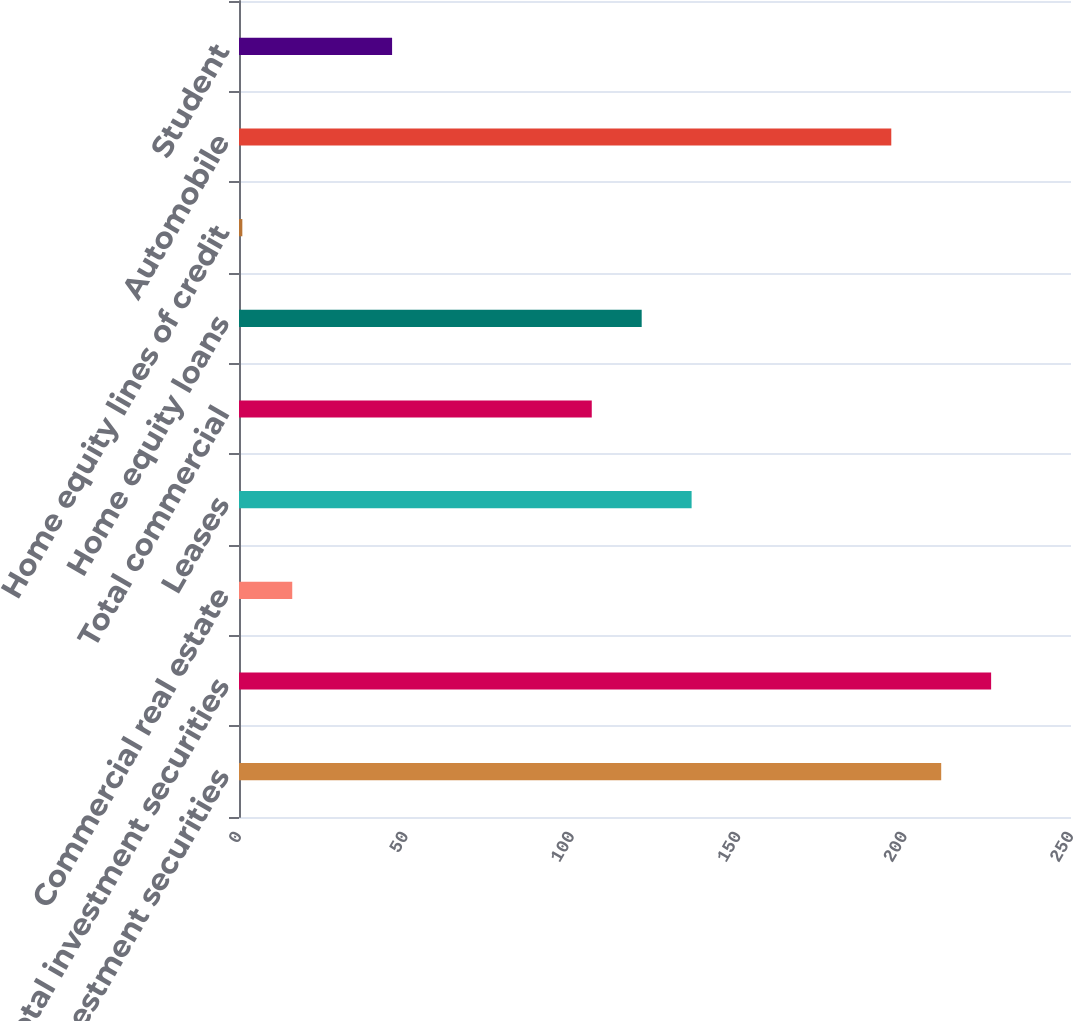Convert chart to OTSL. <chart><loc_0><loc_0><loc_500><loc_500><bar_chart><fcel>Taxable investment securities<fcel>Total investment securities<fcel>Commercial real estate<fcel>Leases<fcel>Total commercial<fcel>Home equity loans<fcel>Home equity lines of credit<fcel>Automobile<fcel>Student<nl><fcel>211<fcel>226<fcel>16<fcel>136<fcel>106<fcel>121<fcel>1<fcel>196<fcel>46<nl></chart> 